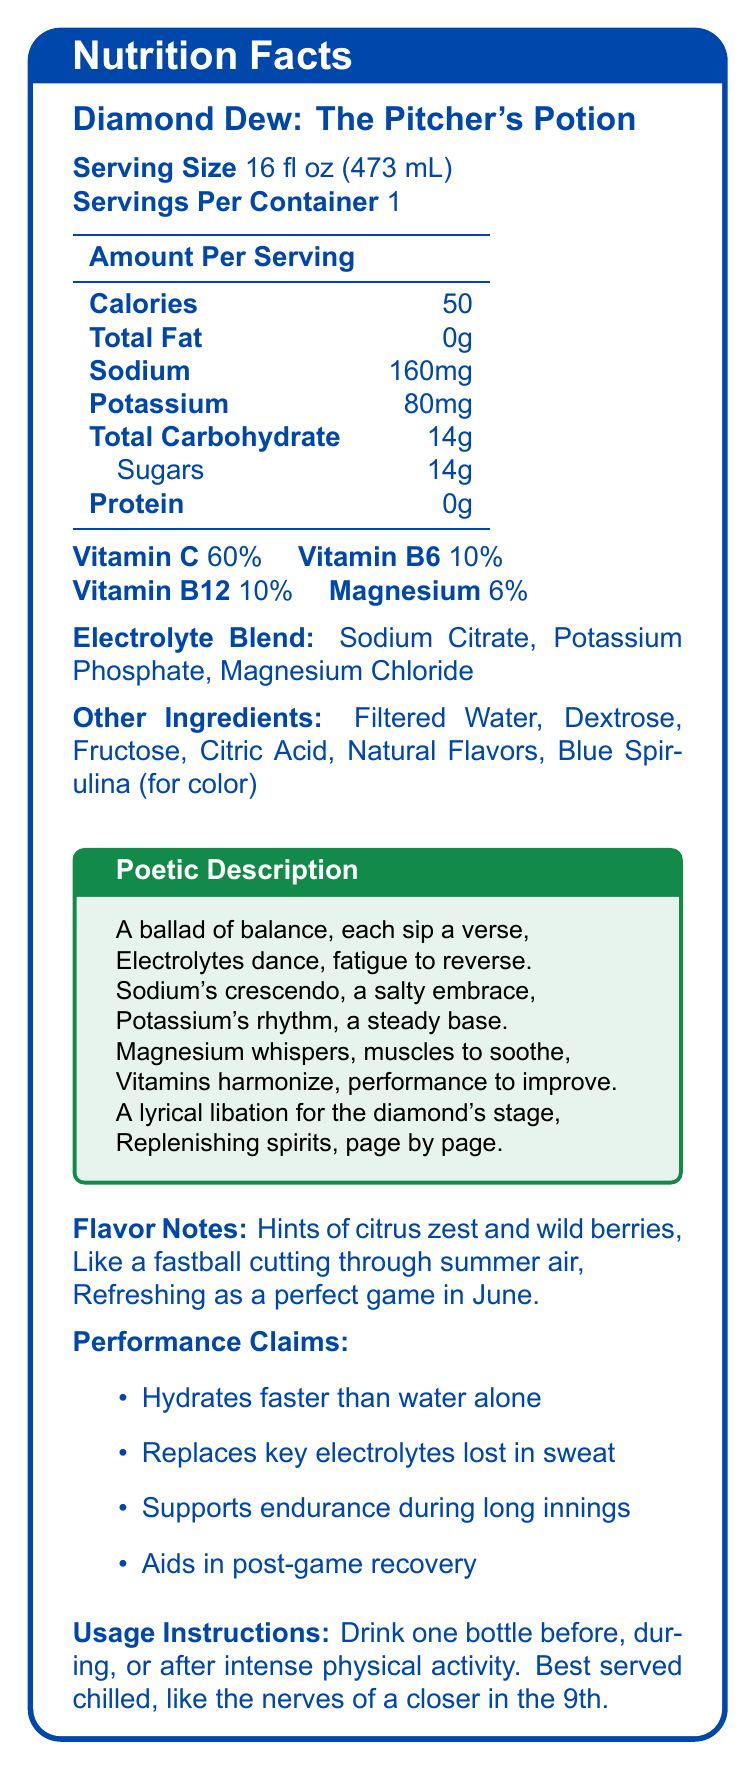who is the intended audience for "Diamond Dew: The Pitcher's Potion"? The document frequently uses baseball-related metaphors, descriptions and highlights endurance and recovery, suggesting its appeal to professional athletes, particularly pitchers.
Answer: Athletes, especially baseball pitchers what is the recommended serving size? The nutrition facts section specifies that the serving size is 16 fl oz (473 mL).
Answer: 16 fl oz (473 mL) how many calories are there per serving? The amount per serving section lists 50 calories.
Answer: 50 what key electrolytes are included in the drink? The electrolyte blend section specifically lists Sodium Citrate, Potassium Phosphate, and Magnesium Chloride.
Answer: Sodium Citrate, Potassium Phosphate, Magnesium Chloride how much sodium does each serving contain? The amount per serving section mentions that there are 160 mg of sodium per serving.
Answer: 160 mg which of the following is a poetic description of the drink? A. "Quenching the thirst of champions" B. "A ballad of balance, each sip a verse" C. "Lightning in a bottle" D. "Smooth as silk on a summer day" The poetic description provided in the document is "A ballad of balance, each sip a verse".
Answer: B which of these flavor notes are highlighted in the description? i. Citrus zest ii. Tropical fruits iii. Wild berries iv. Mint The flavor notes section mentions "Hints of citrus zest and wild berries".
Answer: i and iii does "Diamond Dew: The Pitcher's Potion" contain any protein? The amount per serving section lists the protein content as 0g.
Answer: No is this drink suitable for post-game recovery? The performance claims section includes "Aids in post-game recovery".
Answer: Yes summarize the main idea of the document. The document is a detailed overview of the "Diamond Dew: The Pitcher's Potion", aimed at athletes, describing its nutritional benefits, key ingredients, flavor, performance claims, poetic appeal, and usage.
Answer: The document presents a sports drink called "Diamond Dew: The Pitcher's Potion" designed specifically for athletes, particularly baseball pitchers. It highlights the drink's nutritional content, including key electrolytes and vitamins, and provides flavor notes and poetic descriptions to emphasize its appeal. The document also mentions the drink's performance benefits and usage instructions for optimal hydration and recovery. what additional health benefits does magnesium provide in this drink? The document does not specify additional health benefits of magnesium beyond its inclusion in the electrolyte blend and its contribution to muscle soothing.
Answer: Cannot be determined what percentage of the daily value of Vitamin C does the drink provide? The nutrition facts section specifies that the drink provides 60% of the daily value of Vitamin C.
Answer: 60% which ingredient gives the drink its color? The ingredients section mentions Blue Spirulina is used for color.
Answer: Blue Spirulina does the drink have any fat content? The amount per serving section lists the total fat content as 0g.
Answer: No when is the best time to consume this drink for optimal performance benefits? A. Before intense physical activity B. During intense physical activity C. After intense physical activity D. All of the above The usage instructions recommend drinking the beverage before, during, or after intense physical activity.
Answer: D 